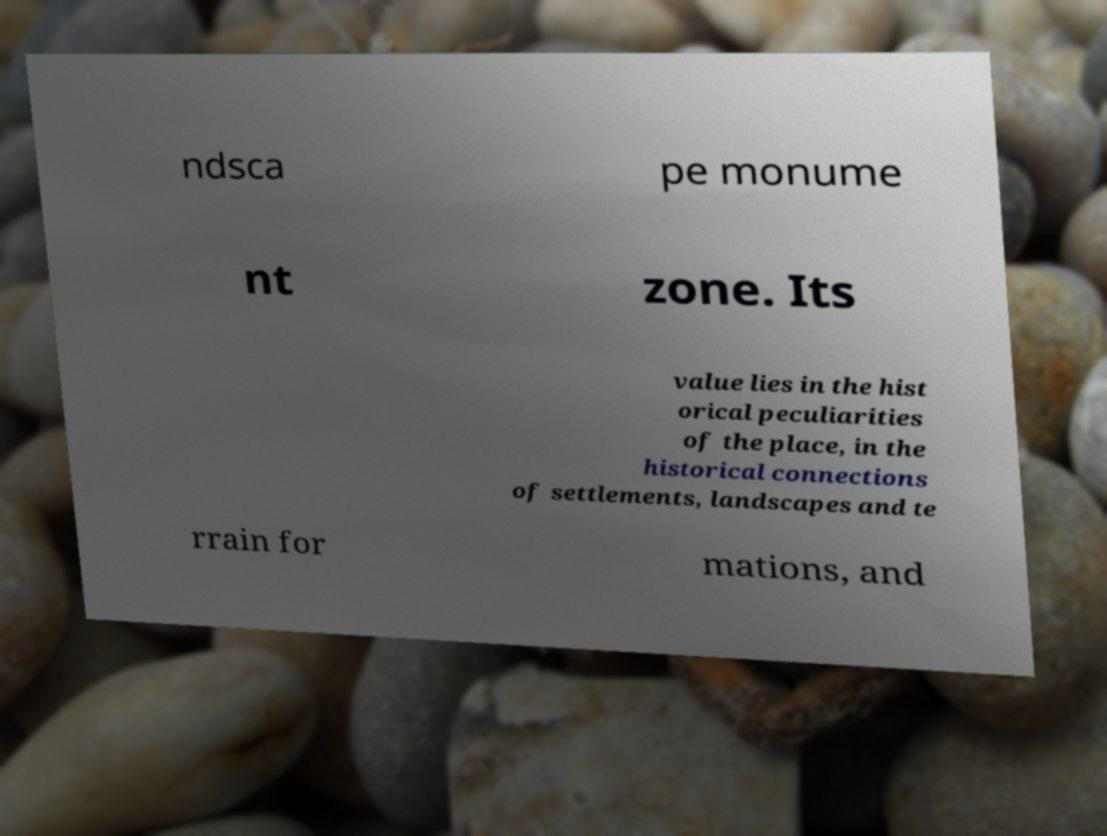Please read and relay the text visible in this image. What does it say? ndsca pe monume nt zone. Its value lies in the hist orical peculiarities of the place, in the historical connections of settlements, landscapes and te rrain for mations, and 